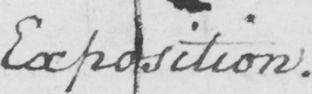Can you read and transcribe this handwriting? Exposition . 